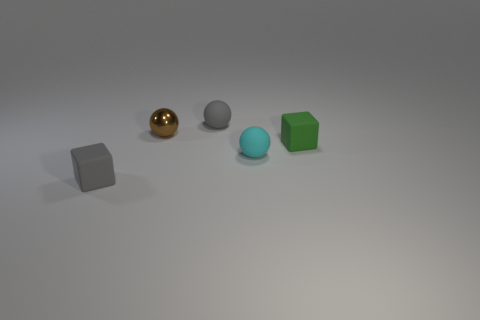Add 2 big cyan blocks. How many objects exist? 7 Subtract 1 green cubes. How many objects are left? 4 Subtract all cubes. How many objects are left? 3 Subtract 3 spheres. How many spheres are left? 0 Subtract all brown spheres. Subtract all brown cylinders. How many spheres are left? 2 Subtract all blue spheres. How many gray blocks are left? 1 Subtract all small cyan rubber objects. Subtract all small green cubes. How many objects are left? 3 Add 4 small metallic spheres. How many small metallic spheres are left? 5 Add 1 blue metallic things. How many blue metallic things exist? 1 Subtract all cyan spheres. How many spheres are left? 2 